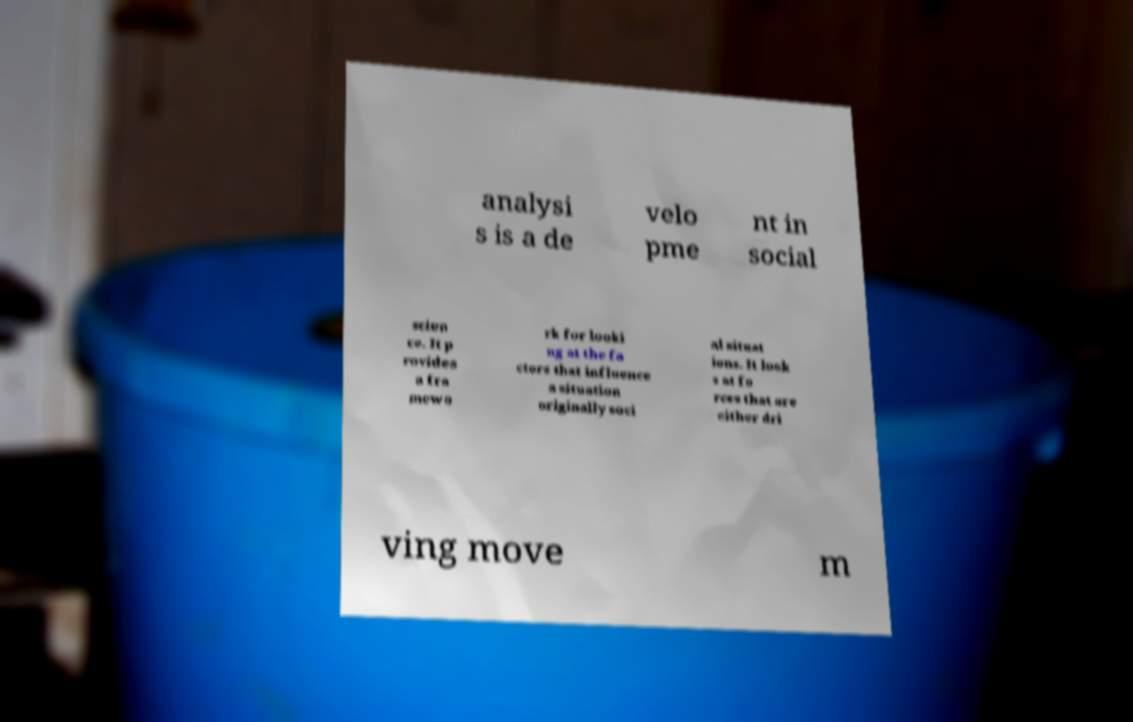Please read and relay the text visible in this image. What does it say? analysi s is a de velo pme nt in social scien ce. It p rovides a fra mewo rk for looki ng at the fa ctors that influence a situation originally soci al situat ions. It look s at fo rces that are either dri ving move m 